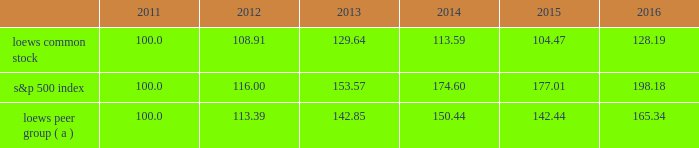Item 5 .
Market for the registrant 2019s common equity , related stockholder matters and issuer purchases of equity securities the following graph compares annual total return of our common stock , the standard & poor 2019s 500 composite stock index ( 201cs&p 500 index 201d ) and our peer group ( 201cloews peer group 201d ) for the five years ended december 31 , 2016 .
The graph assumes that the value of the investment in our common stock , the s&p 500 index and the loews peer group was $ 100 on december 31 , 2011 and that all dividends were reinvested. .
( a ) the loews peer group consists of the following companies that are industry competitors of our principal operating subsidiaries : chubb limited ( name change from ace limited after it acquired the chubb corporation on january 15 , 2016 ) , w.r .
Berkley corporation , the chubb corporation ( included through january 15 , 2016 when it was acquired by ace limited ) , energy transfer partners l.p. , ensco plc , the hartford financial services group , inc. , kinder morgan energy partners , l.p .
( included through november 26 , 2014 when it was acquired by kinder morgan inc. ) , noble corporation , spectra energy corp , transocean ltd .
And the travelers companies , inc .
Dividend information we have paid quarterly cash dividends in each year since 1967 .
Regular dividends of $ 0.0625 per share of loews common stock were paid in each calendar quarter of 2016 and 2015. .
What was the growth rate of the s&p 500 index from 2011 to 2016? 
Rationale: to find the growth rate you divide the change in the amounts by the earliest amount
Computations: ((198.18 - 100.0) / 100)
Answer: 0.9818. 